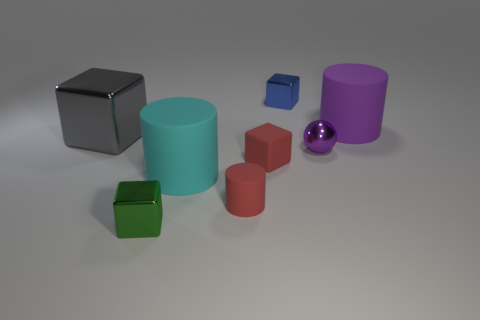Is there any other thing that has the same shape as the purple metallic thing?
Your response must be concise. No. Are there an equal number of tiny metal cubes that are in front of the purple metal thing and tiny green rubber objects?
Offer a terse response. No. What is the shape of the small thing that is to the right of the cyan matte cylinder and in front of the large cyan object?
Make the answer very short. Cylinder. Does the red rubber cylinder have the same size as the purple sphere?
Your answer should be very brief. Yes. Is there a tiny blue block that has the same material as the tiny ball?
Your answer should be very brief. Yes. The matte cylinder that is the same color as the matte block is what size?
Provide a short and direct response. Small. How many shiny blocks are in front of the big purple rubber thing and behind the cyan object?
Offer a terse response. 1. What is the large cylinder that is in front of the small purple sphere made of?
Your response must be concise. Rubber. How many metallic blocks have the same color as the small matte cylinder?
Make the answer very short. 0. There is a red block that is made of the same material as the large cyan cylinder; what size is it?
Make the answer very short. Small. 